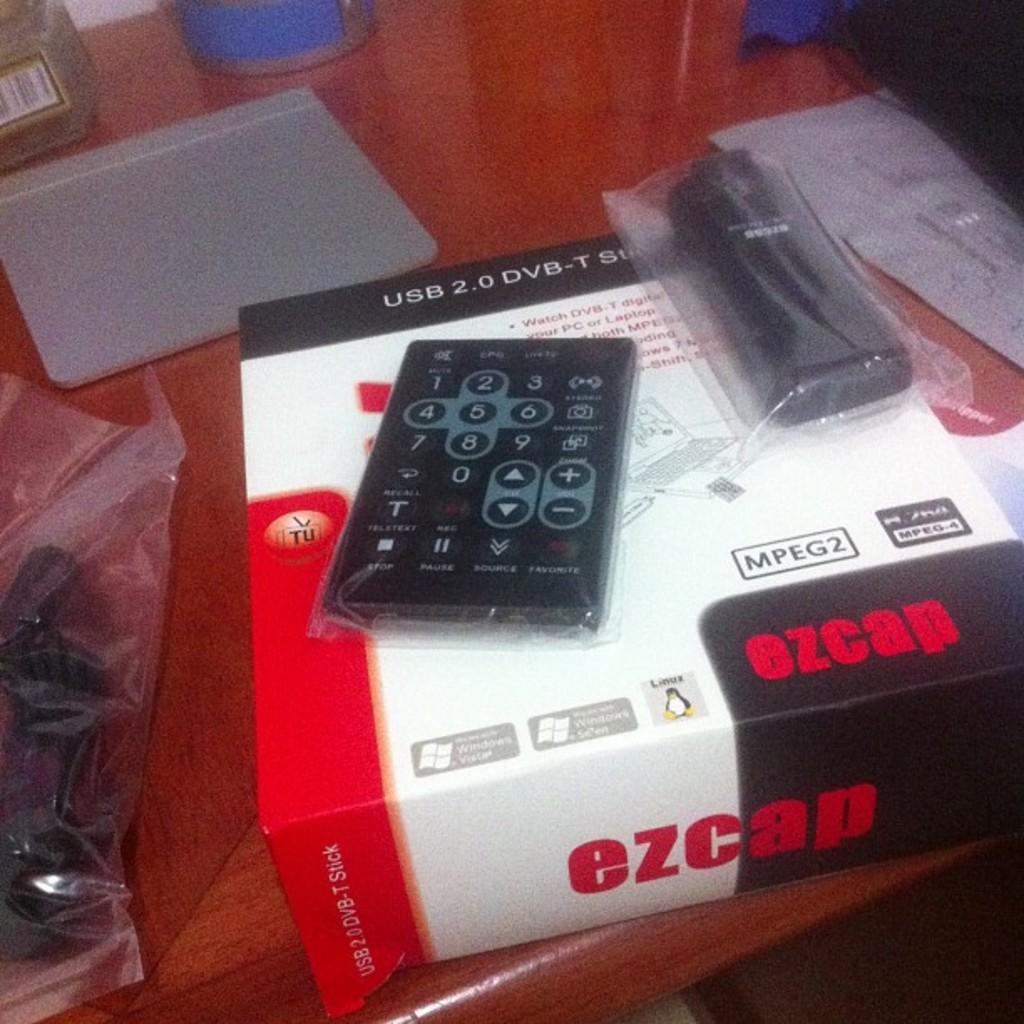What version is this usb?
Provide a succinct answer. 2.0. What brand is this?
Your answer should be compact. Ezcap. 